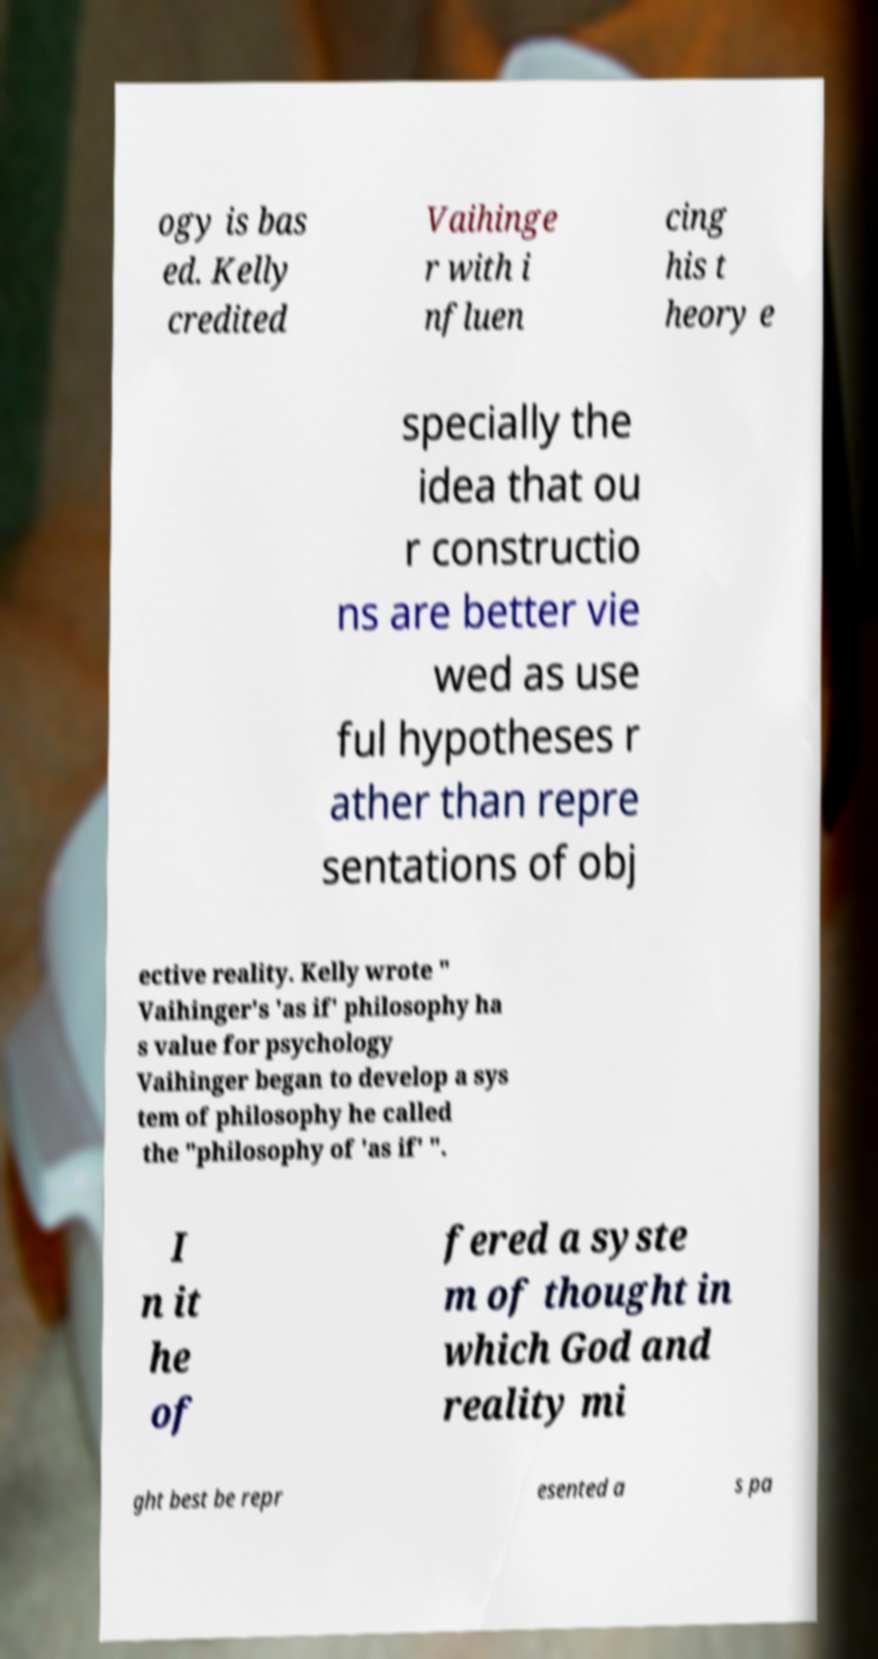There's text embedded in this image that I need extracted. Can you transcribe it verbatim? ogy is bas ed. Kelly credited Vaihinge r with i nfluen cing his t heory e specially the idea that ou r constructio ns are better vie wed as use ful hypotheses r ather than repre sentations of obj ective reality. Kelly wrote " Vaihinger's 'as if' philosophy ha s value for psychology Vaihinger began to develop a sys tem of philosophy he called the "philosophy of 'as if' ". I n it he of fered a syste m of thought in which God and reality mi ght best be repr esented a s pa 